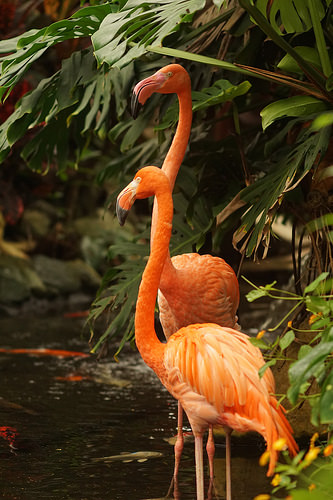<image>
Can you confirm if the flamingo is under the flamingo? No. The flamingo is not positioned under the flamingo. The vertical relationship between these objects is different. 